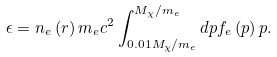Convert formula to latex. <formula><loc_0><loc_0><loc_500><loc_500>\epsilon = n _ { e } \left ( r \right ) m _ { e } c ^ { 2 } \int ^ { M _ { \chi } / m _ { e } } _ { 0 . 0 1 M _ { \chi } / m _ { e } } d p f _ { e } \left ( p \right ) p .</formula> 